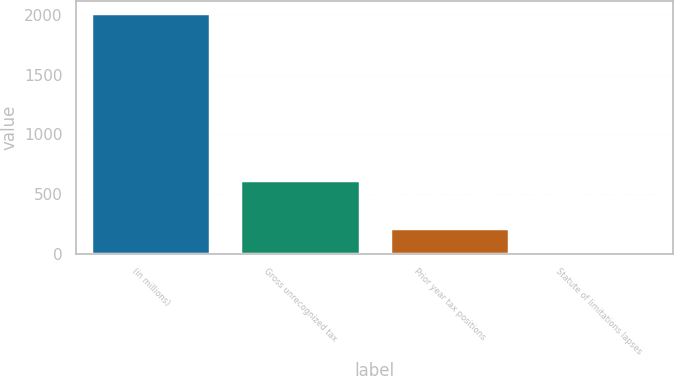<chart> <loc_0><loc_0><loc_500><loc_500><bar_chart><fcel>(in millions)<fcel>Gross unrecognized tax<fcel>Prior year tax positions<fcel>Statute of limitations lapses<nl><fcel>2016<fcel>613.2<fcel>212.4<fcel>12<nl></chart> 